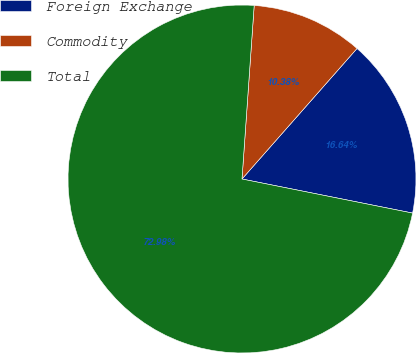Convert chart. <chart><loc_0><loc_0><loc_500><loc_500><pie_chart><fcel>Foreign Exchange<fcel>Commodity<fcel>Total<nl><fcel>16.64%<fcel>10.38%<fcel>72.97%<nl></chart> 